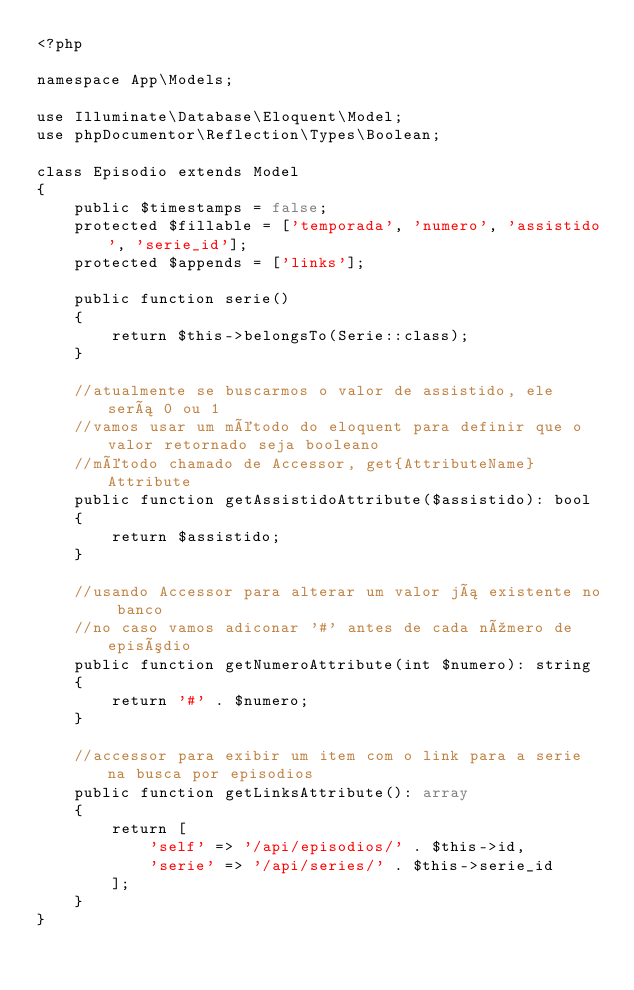<code> <loc_0><loc_0><loc_500><loc_500><_PHP_><?php

namespace App\Models;

use Illuminate\Database\Eloquent\Model;
use phpDocumentor\Reflection\Types\Boolean;

class Episodio extends Model
{
    public $timestamps = false;
    protected $fillable = ['temporada', 'numero', 'assistido', 'serie_id'];
    protected $appends = ['links'];

    public function serie() 
    {
        return $this->belongsTo(Serie::class);    
    }

    //atualmente se buscarmos o valor de assistido, ele será 0 ou 1
    //vamos usar um método do eloquent para definir que o valor retornado seja booleano
    //método chamado de Accessor, get{AttributeName}Attribute
    public function getAssistidoAttribute($assistido): bool
    {
        return $assistido;
    } 

    //usando Accessor para alterar um valor já existente no banco
    //no caso vamos adiconar '#' antes de cada número de episódio
    public function getNumeroAttribute(int $numero): string
    {
        return '#' . $numero;
    }

    //accessor para exibir um item com o link para a serie na busca por episodios
    public function getLinksAttribute(): array
    {
        return [
            'self' => '/api/episodios/' . $this->id,
            'serie' => '/api/series/' . $this->serie_id
        ];
    }
}</code> 